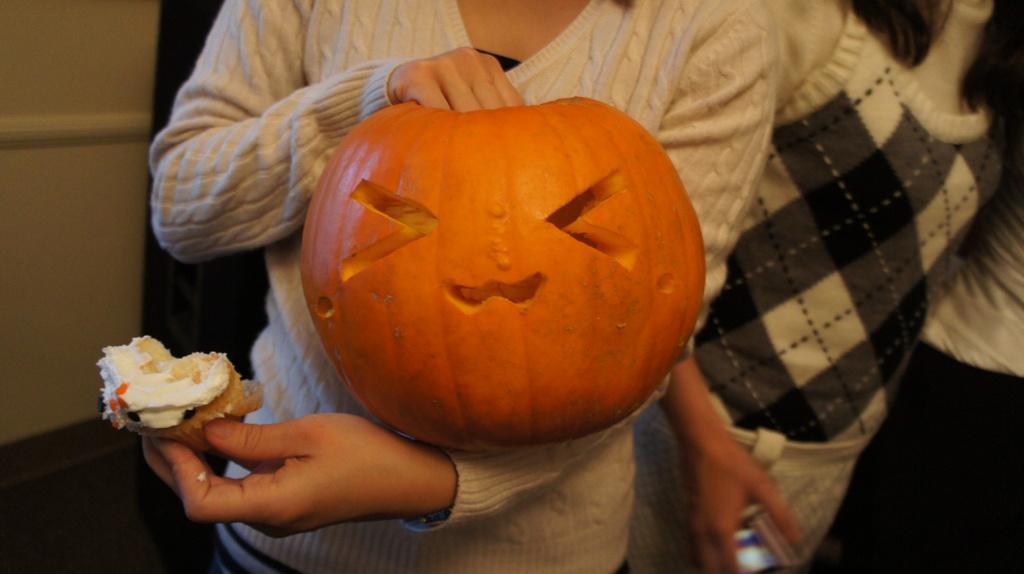How would you summarize this image in a sentence or two? In this picture there is a person standing and holding a pumpkin and food, beside her we can see another person. In the background of the image it is dark and we can see wall and floor. 